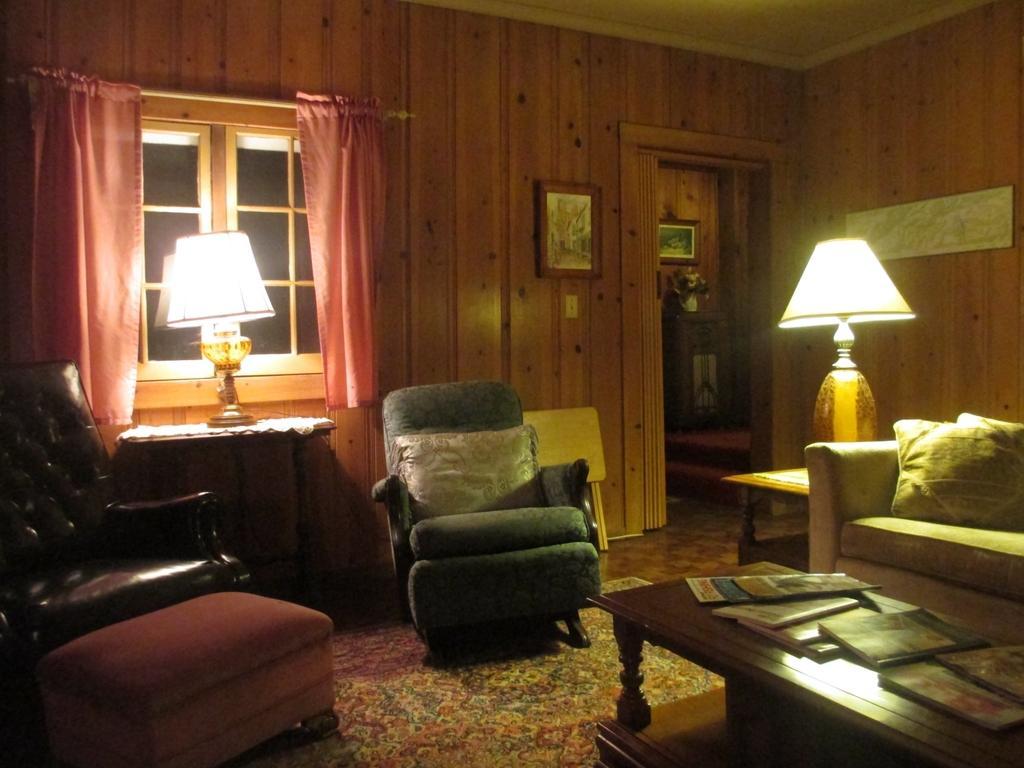Could you give a brief overview of what you see in this image? Two chairs,two lamps,a sofa and a table are arranged in a living room. 